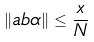Convert formula to latex. <formula><loc_0><loc_0><loc_500><loc_500>\| a b \alpha \| \leq \frac { x } { N }</formula> 